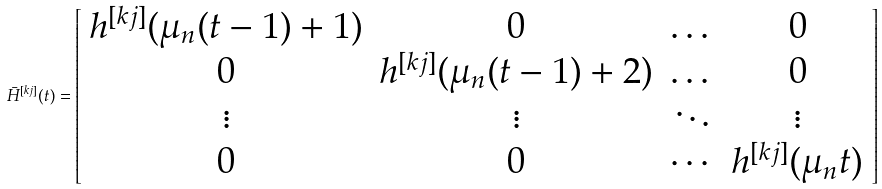<formula> <loc_0><loc_0><loc_500><loc_500>\bar { H } ^ { [ k j ] } ( t ) = \left [ \begin{array} { c c c c } h ^ { [ k j ] } ( \mu _ { n } ( t - 1 ) + 1 ) & 0 & \dots & 0 \\ 0 & h ^ { [ k j ] } ( \mu _ { n } ( t - 1 ) + 2 ) & \dots & 0 \\ \vdots & \vdots & \ddots & \vdots \\ 0 & 0 & \cdots & h ^ { [ k j ] } ( \mu _ { n } t ) \end{array} \right ]</formula> 